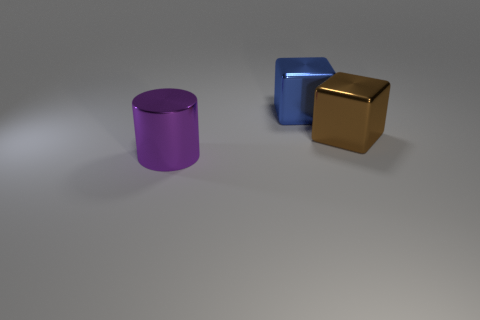Add 1 big shiny cylinders. How many objects exist? 4 Subtract 2 blocks. How many blocks are left? 0 Subtract all cubes. How many objects are left? 1 Subtract all gray balls. How many brown cylinders are left? 0 Subtract all tiny green matte blocks. Subtract all big blocks. How many objects are left? 1 Add 3 blue blocks. How many blue blocks are left? 4 Add 1 big blue blocks. How many big blue blocks exist? 2 Subtract 0 cyan cubes. How many objects are left? 3 Subtract all cyan cubes. Subtract all brown spheres. How many cubes are left? 2 